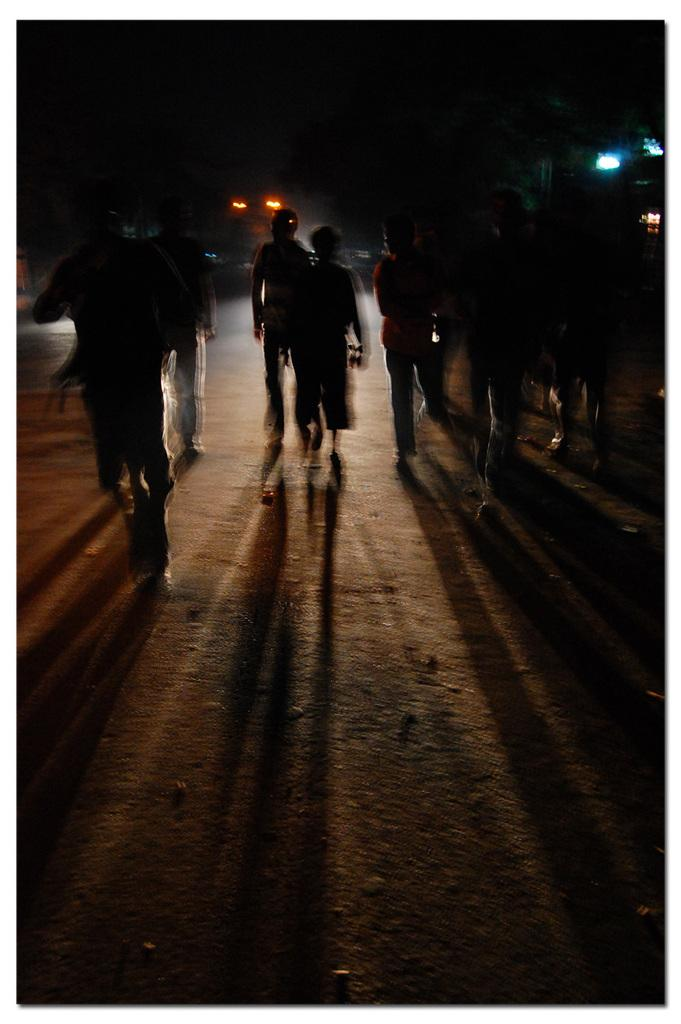What are the persons in the image doing? The persons in the image are walking on the road. Can you describe the lighting in the image? There is a light behind the persons, and there are other lights visible in the background. What type of tray can be seen being carried by the persons in the image? There is no tray visible in the image; the persons are simply walking on the road. What appliance is making noise in the background of the image? There is no appliance making noise in the background of the image; the focus is on the persons walking and the lights visible. 